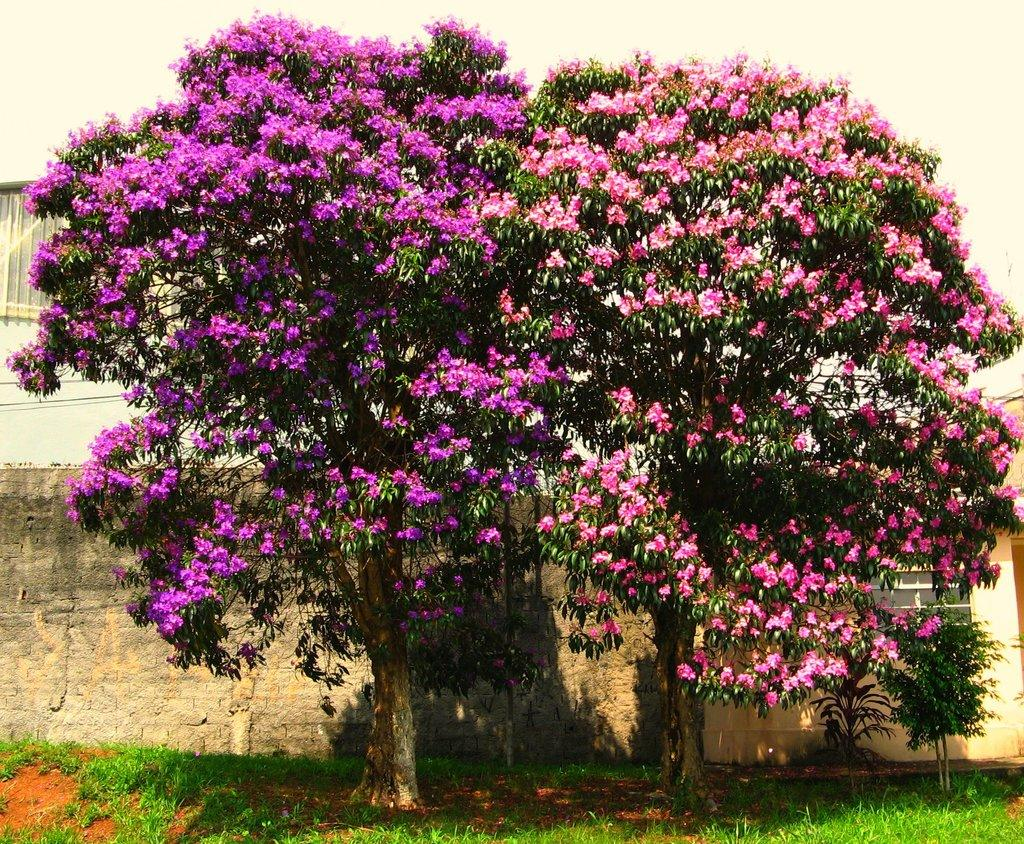What type of vegetation can be seen in the image? There are trees and flowers visible in the image. What is at the bottom of the image? There is grass at the bottom of the image. What can be seen in the background of the image? There is a wall and a building in the background of the image. What type of cake is being served on the wheelchair in the image? There is no wheelchair or cake present in the image; it features trees, flowers, grass, a wall, and a building. 